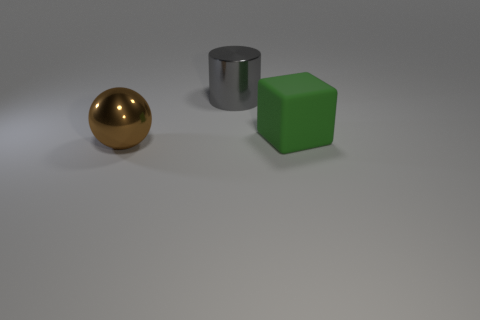Are there any other things that have the same material as the green object?
Offer a very short reply. No. Is the material of the big thing that is in front of the green matte object the same as the gray thing?
Provide a short and direct response. Yes. The shiny thing that is in front of the large green cube is what color?
Your answer should be compact. Brown. Are there any other cylinders of the same size as the metal cylinder?
Keep it short and to the point. No. There is a block that is the same size as the gray metal object; what is it made of?
Offer a terse response. Rubber. Does the matte object have the same size as the metal thing that is in front of the green rubber cube?
Provide a succinct answer. Yes. There is a large object behind the block; what material is it?
Make the answer very short. Metal. Is the number of green rubber cubes in front of the large sphere the same as the number of big brown rubber spheres?
Your response must be concise. Yes. Is the size of the gray metallic cylinder the same as the brown metallic sphere?
Your answer should be compact. Yes. There is a metal object that is on the left side of the large metallic object right of the big brown object; are there any big rubber objects to the right of it?
Your answer should be very brief. Yes. 